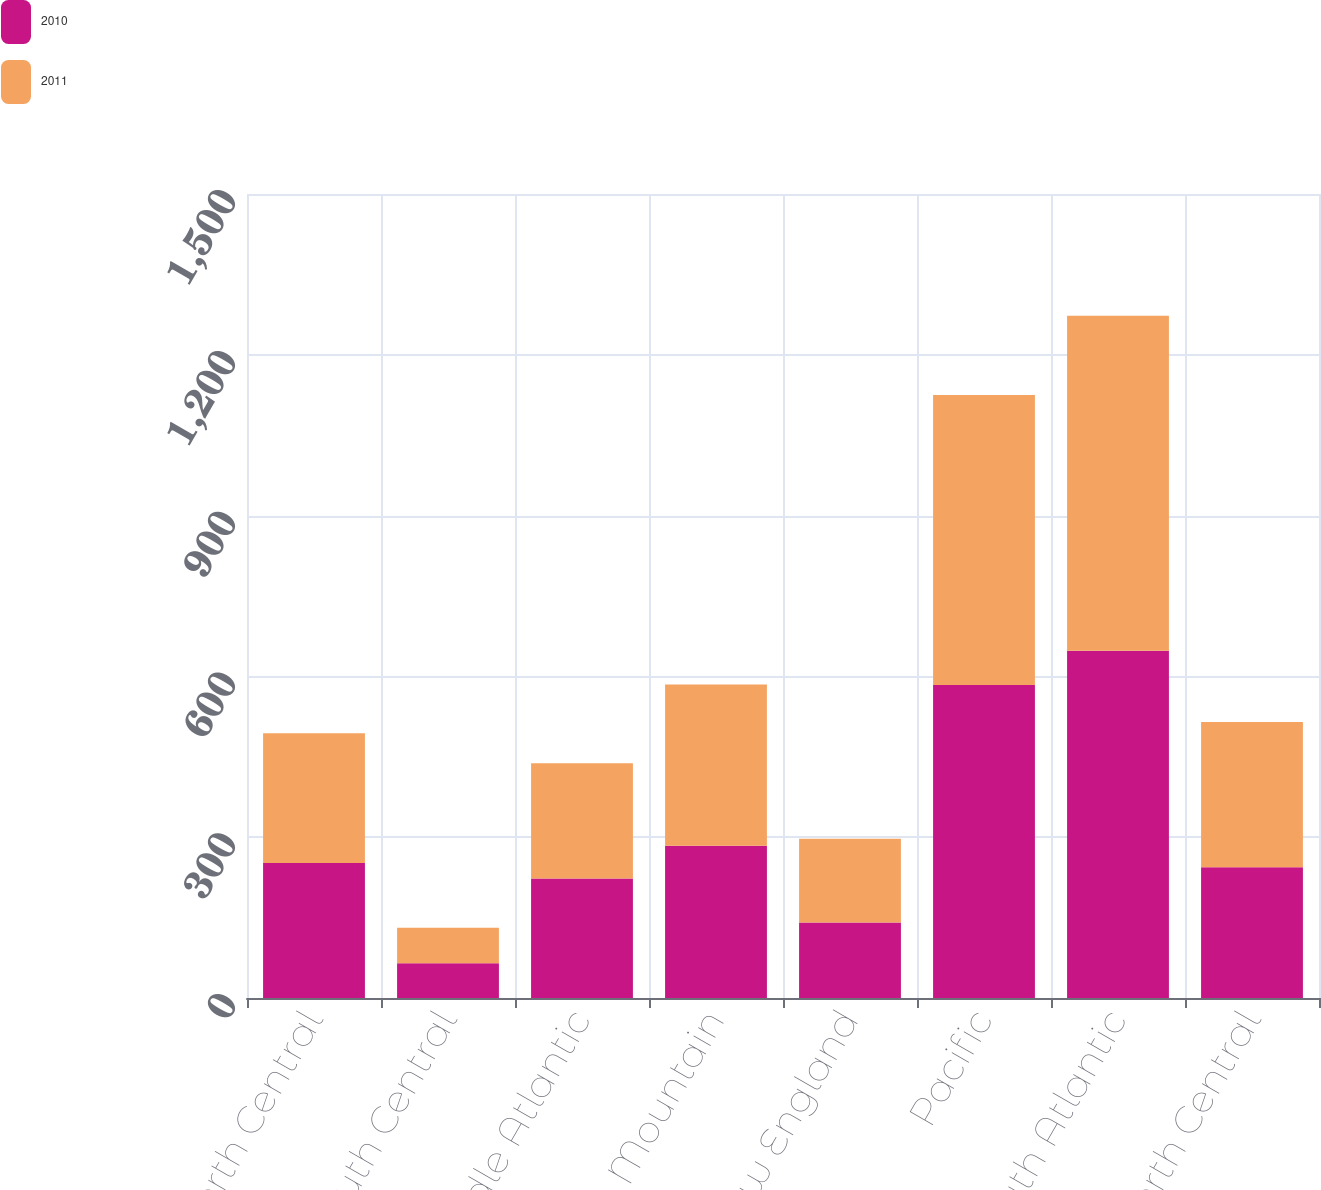Convert chart to OTSL. <chart><loc_0><loc_0><loc_500><loc_500><stacked_bar_chart><ecel><fcel>East North Central<fcel>East South Central<fcel>Middle Atlantic<fcel>Mountain<fcel>New England<fcel>Pacific<fcel>South Atlantic<fcel>West North Central<nl><fcel>2010<fcel>252<fcel>65<fcel>223<fcel>284<fcel>141<fcel>584<fcel>648<fcel>244<nl><fcel>2011<fcel>242<fcel>66<fcel>215<fcel>301<fcel>156<fcel>541<fcel>625<fcel>271<nl></chart> 